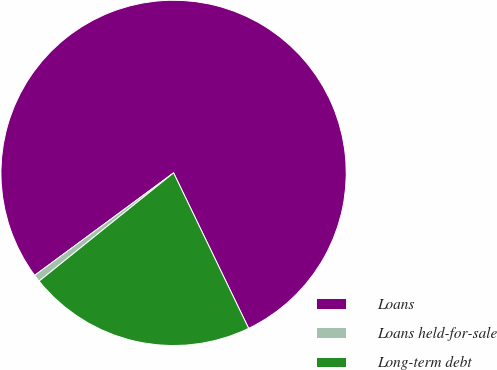Convert chart to OTSL. <chart><loc_0><loc_0><loc_500><loc_500><pie_chart><fcel>Loans<fcel>Loans held-for-sale<fcel>Long-term debt<nl><fcel>77.95%<fcel>0.67%<fcel>21.37%<nl></chart> 